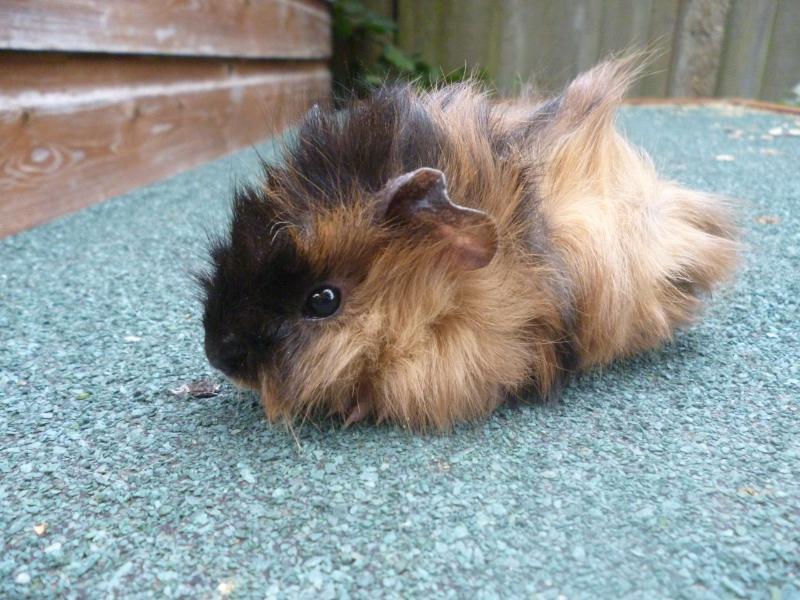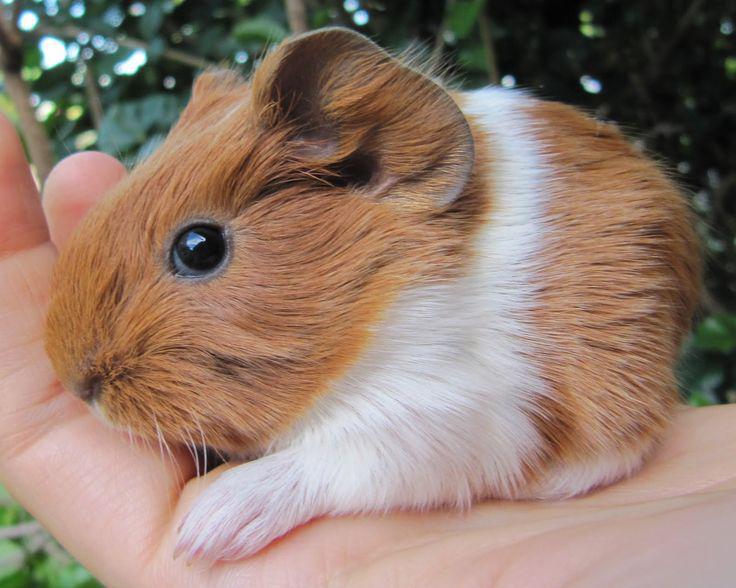The first image is the image on the left, the second image is the image on the right. For the images displayed, is the sentence "In one image, three gerbils are being held in one or more human hands that have the palm up and fingers extended." factually correct? Answer yes or no. No. The first image is the image on the left, the second image is the image on the right. Evaluate the accuracy of this statement regarding the images: "Three hamsters are held in human hands in one image.". Is it true? Answer yes or no. No. The first image is the image on the left, the second image is the image on the right. For the images shown, is this caption "An image shows an extended hand holding at least one hamster." true? Answer yes or no. Yes. The first image is the image on the left, the second image is the image on the right. Examine the images to the left and right. Is the description "In one image, at least one rodent is being held in a human hand" accurate? Answer yes or no. Yes. 